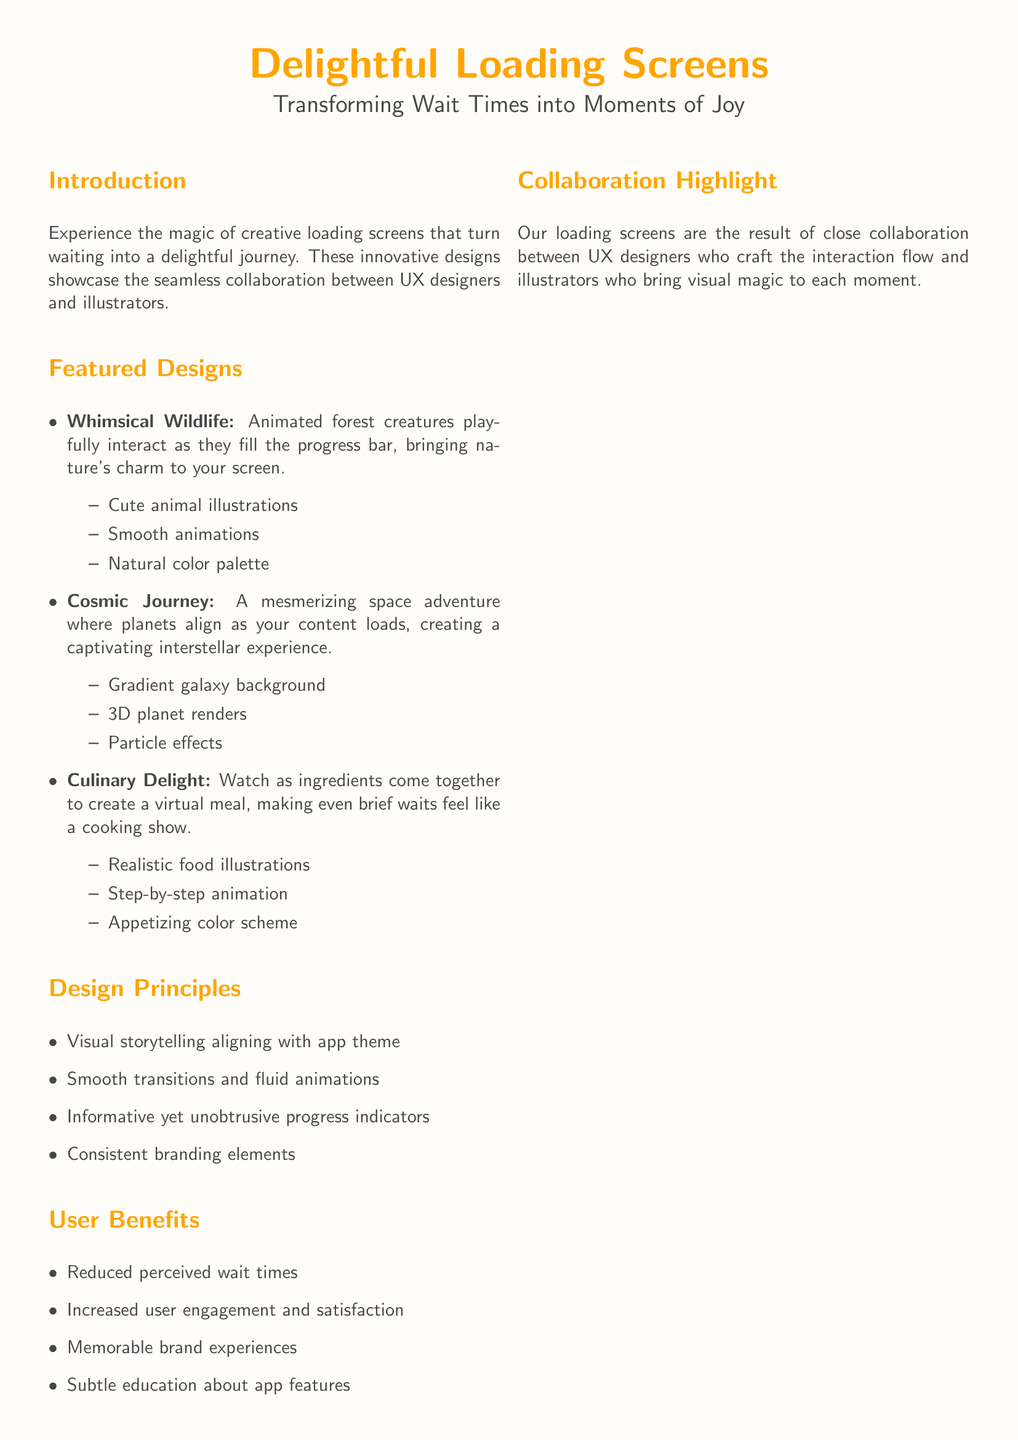What is the title of the catalog? The title is prominently displayed at the top of the document.
Answer: Delightful Loading Screens How many featured designs are listed? The number of designs is indicated in the "Featured Designs" section.
Answer: Three What is the theme of the first featured design? It is described at the beginning of the "Featured Designs" section.
Answer: Whimsical Wildlife What type of background is used in "Cosmic Journey"? The type of background is mentioned in the description of the second featured design.
Answer: Gradient galaxy background What are the user benefits mentioned in the document? They are enumerated in the "User Benefits" section.
Answer: Reduced perceived wait times Which design includes food illustrations? This design is specified in the "Featured Designs" section.
Answer: Culinary Delight What do UX designers and illustrators collaborate on? This is clarified in the "Collaboration Highlight" section.
Answer: Loading screens What color is used for the accent in the document? This information is found in the color definitions at the beginning.
Answer: Orange 